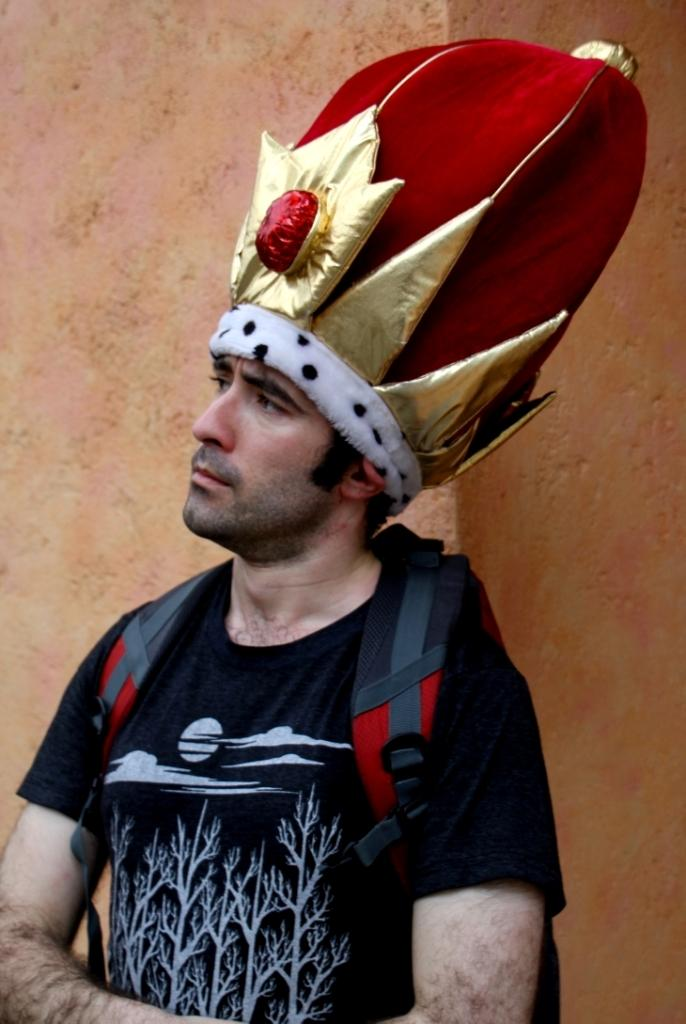Who is present in the image? There is a man in the image. What is the man doing in the image? The man is standing in the image. What is the man wearing on his back? The man is wearing a backpack on his back. What is the man wearing on his head? The man is wearing a cap on his head. What color is the t-shirt the man is wearing? The man is wearing a black color t-shirt. What can be seen in the background of the image? There is a wall visible in the image. What type of quiver is the man carrying on his back? The man is not carrying a quiver in the image; he is carrying a backpack. What type of low, can be seen in the image? There is no reference to "low" in the image, so it cannot be determined what type of low might be present. 